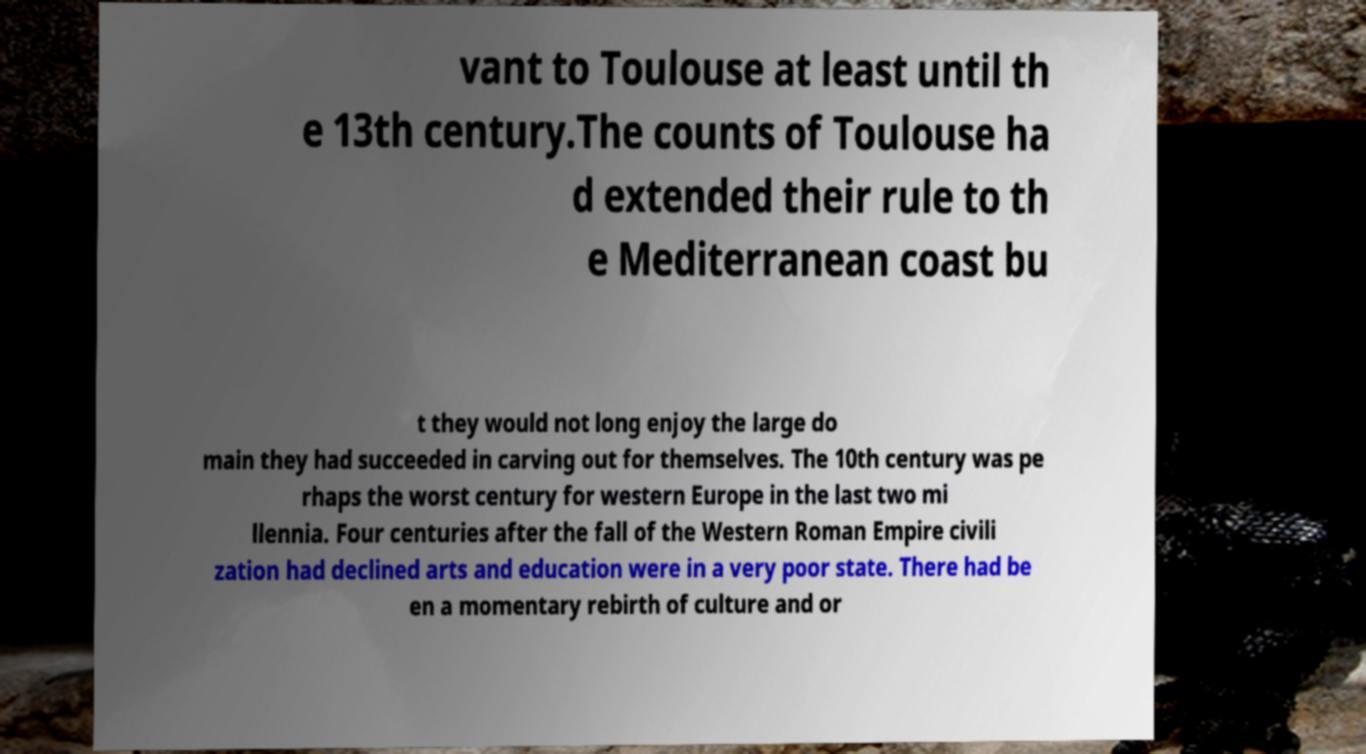Could you assist in decoding the text presented in this image and type it out clearly? vant to Toulouse at least until th e 13th century.The counts of Toulouse ha d extended their rule to th e Mediterranean coast bu t they would not long enjoy the large do main they had succeeded in carving out for themselves. The 10th century was pe rhaps the worst century for western Europe in the last two mi llennia. Four centuries after the fall of the Western Roman Empire civili zation had declined arts and education were in a very poor state. There had be en a momentary rebirth of culture and or 